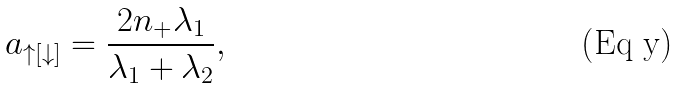Convert formula to latex. <formula><loc_0><loc_0><loc_500><loc_500>a _ { \uparrow [ \downarrow ] } = \frac { 2 n _ { + } \lambda _ { 1 } } { \lambda _ { 1 } + \lambda _ { 2 } } ,</formula> 